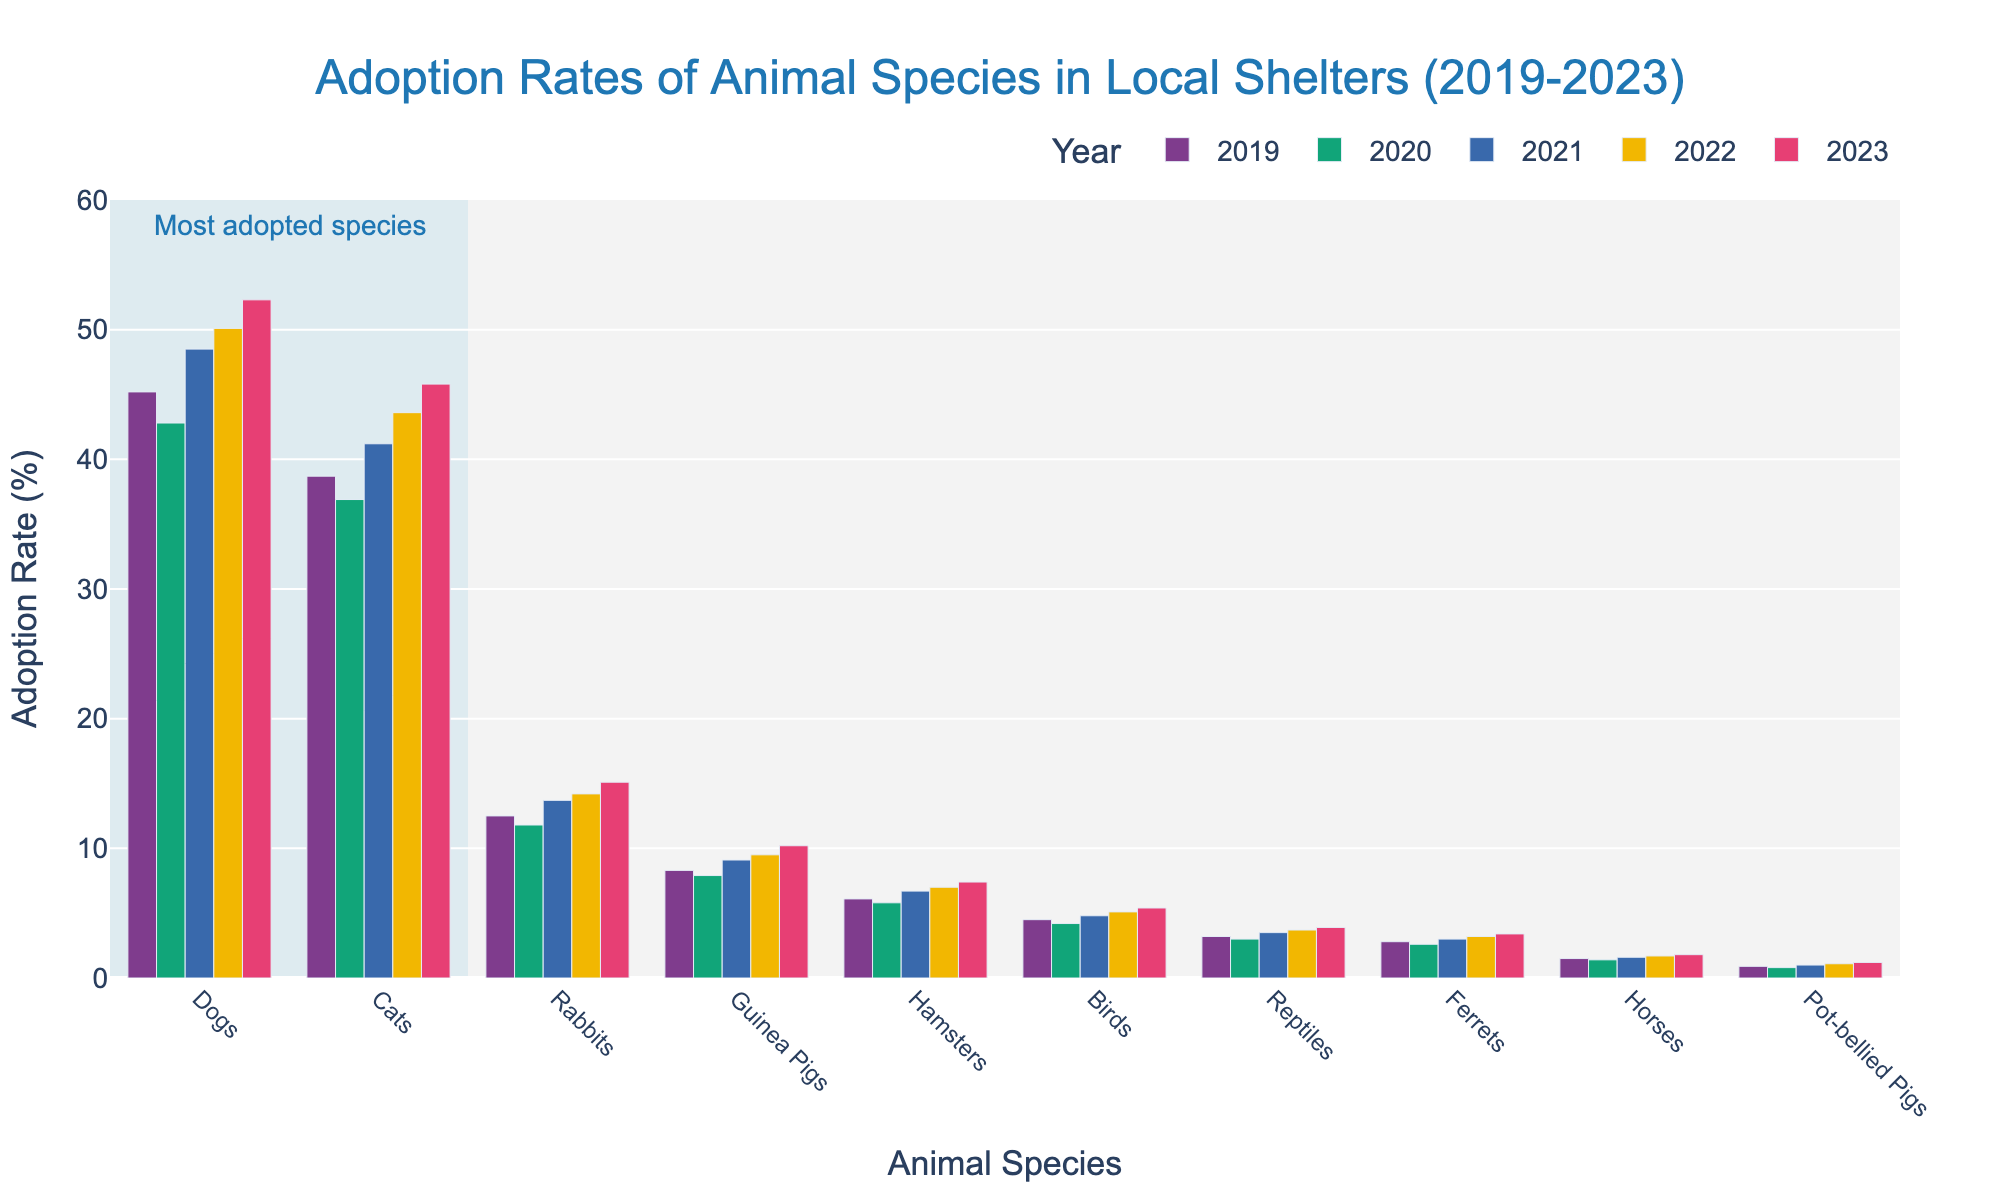What animal species had the highest adoption rate in 2023? The tallest bar in 2023 corresponds to Dogs, indicating they had the highest adoption rate.
Answer: Dogs How did rabbit adoption rates change from 2019 to 2023? Look at the rabbit bars across the years and note the change from 12.5% in 2019 to 15.1% in 2023. Subtract the 2019 rate from the 2023 rate to find the change.
Answer: Increased by 2.6% Which animal species had the smallest increase in adoption rate between 2019 and 2023? Compare the differences in adoption rates from 2019 to 2023 for all species. Ferrets increased from 2.8% to 3.4%, which is the smallest increase (0.6%).
Answer: Ferrets For which year did hamsters see the highest adoption rate? Look at the bars for hamsters across the years, find that the height is greatest in 2023, which corresponds to the highest adoption rate.
Answer: 2023 Did the adoption rate for guinea pigs ever decrease over the years? Check the guinea pigs bars for any year-to-year decrease. The rates are 8.3%, 7.9%, 9.1%, 9.5%, and 10.2%, with a decrease only from 2019 to 2020.
Answer: Yes What's the total adoption rate for cats over the 5 years? Sum the rates for cats over all years: 38.7 + 36.9 + 41.2 + 43.6 + 45.8 = 206.2%.
Answer: 206.2% Compare the adoption rates of dogs and cats in 2023. Which is higher and by how much? In 2023, dogs have an adoption rate of 52.3%, and cats have 45.8%. Subtract cats' rate from dogs' rate to find the difference: 52.3% - 45.8% = 6.5%.
Answer: Dogs by 6.5% Which species had the most improvement in adoption rates between 2019 and 2023? Calculate the rate differences for each species from 2019 to 2023. Dogs increased from 45.2% to 52.3% (7.1%), which is the highest improvement among all species.
Answer: Dogs Are there any species where the adoption rate consistently increased year by year from 2019 to 2023? Check each species' adoption rates for a year-by-year increase. Rabbits' rates go from 12.5%, 11.8%, 13.7%, 14.2%, to 15.1% showing no consistent increase every year. Similarly, Dogs' rates consistently increase from 2019 to 2023.
Answer: Yes, Dogs In which year did birds have the lowest adoption rate? Identify the shortest bar for birds. Their adoption rates are 4.5%, 4.2%, 4.8%, 5.1%, and 5.4%. The lowest is in 2020 at 4.2%.
Answer: 2020 